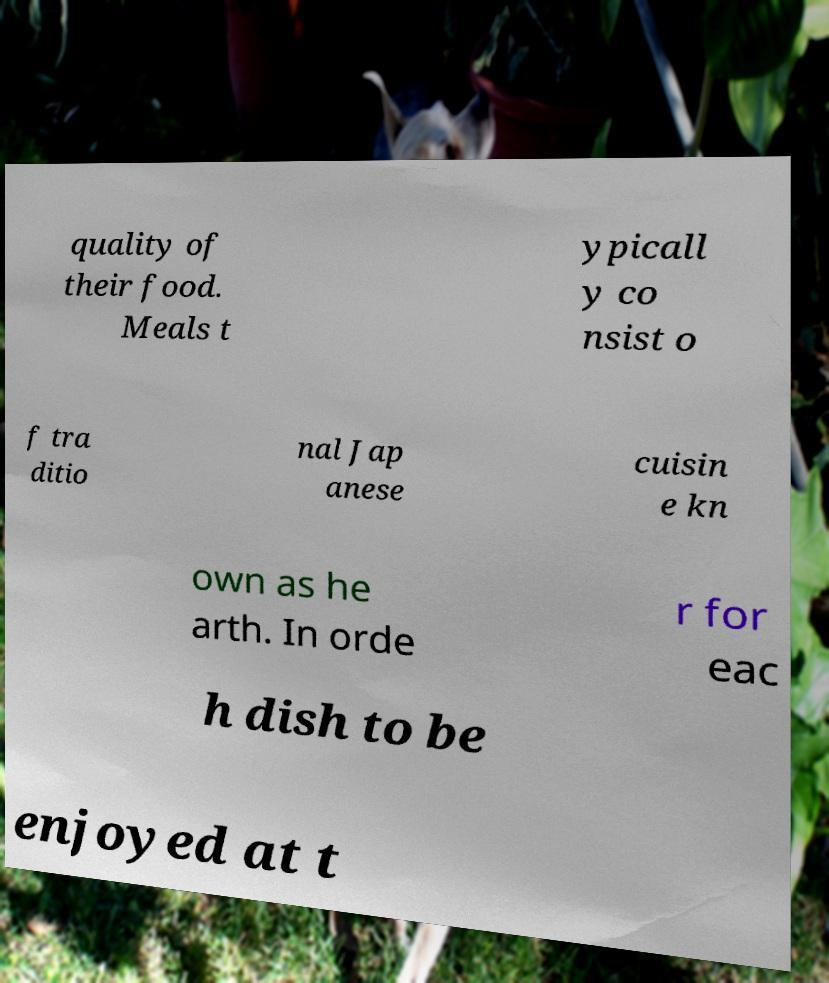Please read and relay the text visible in this image. What does it say? quality of their food. Meals t ypicall y co nsist o f tra ditio nal Jap anese cuisin e kn own as he arth. In orde r for eac h dish to be enjoyed at t 